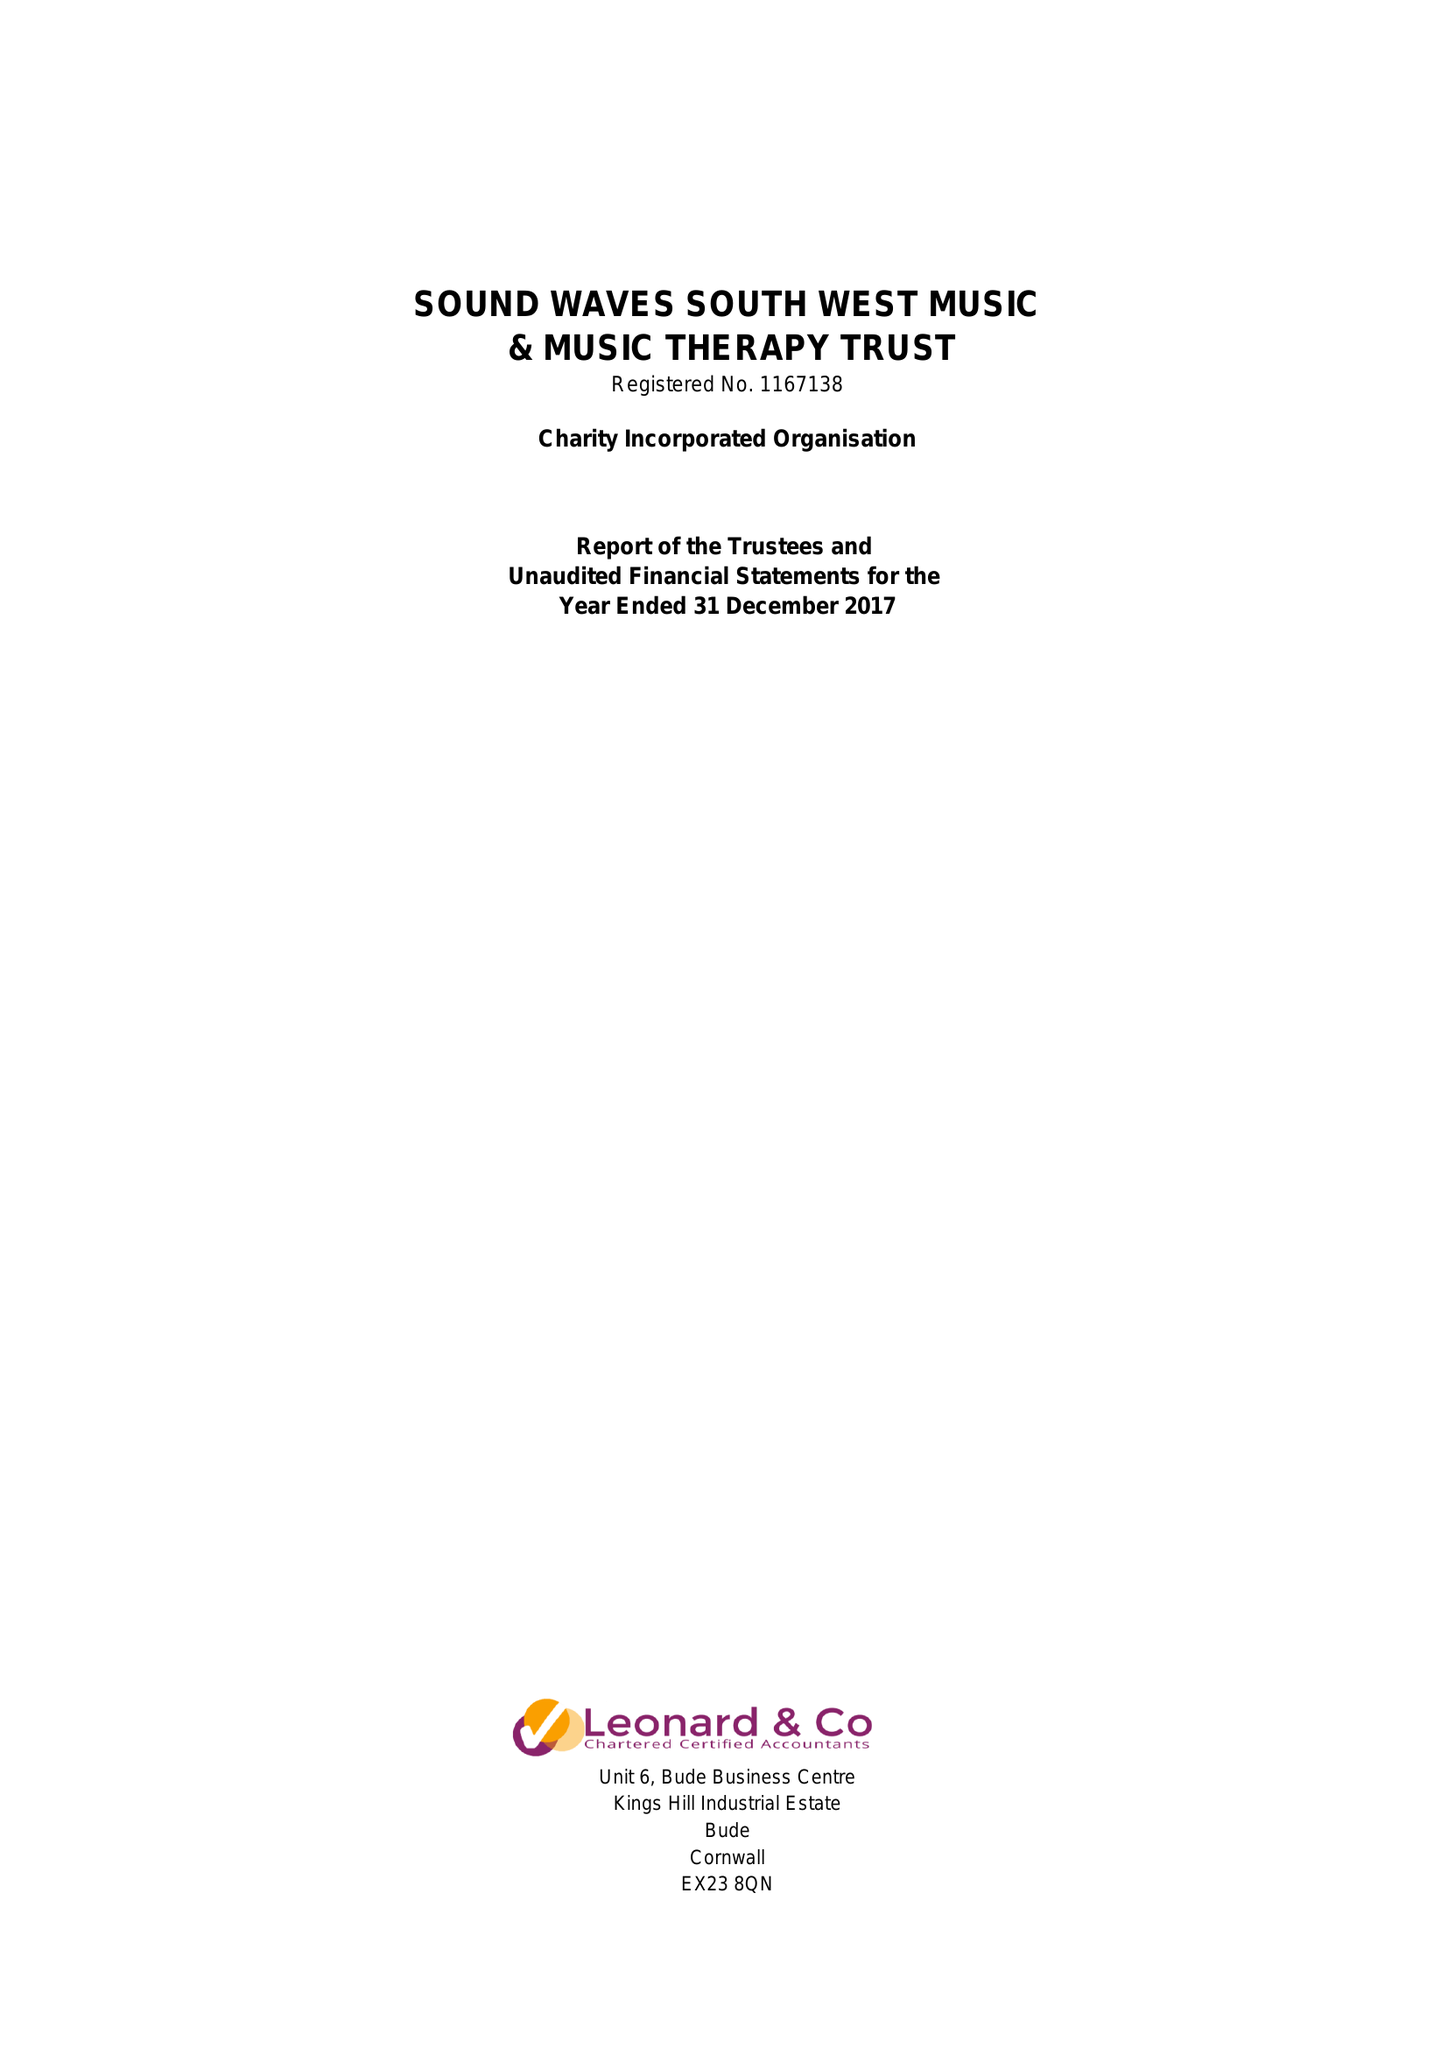What is the value for the charity_name?
Answer the question using a single word or phrase. Sound Waves South West Music and Music Therapy Trust 